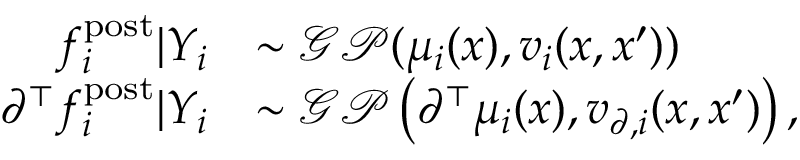Convert formula to latex. <formula><loc_0><loc_0><loc_500><loc_500>\begin{array} { r l } { f _ { i } ^ { p o s t } | Y _ { i } } & { \sim \mathcal { G P } ( \mu _ { i } ( x ) , v _ { i } ( x , x ^ { \prime } ) ) } \\ { \partial ^ { \top } f _ { i } ^ { p o s t } | Y _ { i } } & { \sim \mathcal { G P } \left ( \partial ^ { \top } \mu _ { i } ( x ) , v _ { \partial , i } ( x , x ^ { \prime } ) \right ) , } \end{array}</formula> 